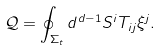<formula> <loc_0><loc_0><loc_500><loc_500>\mathcal { Q } = \oint _ { \Sigma _ { t } } d ^ { d - 1 } S ^ { i } T _ { i j } \xi ^ { j } .</formula> 